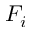<formula> <loc_0><loc_0><loc_500><loc_500>F _ { i }</formula> 